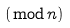<formula> <loc_0><loc_0><loc_500><loc_500>( { \bmod { n } } )</formula> 